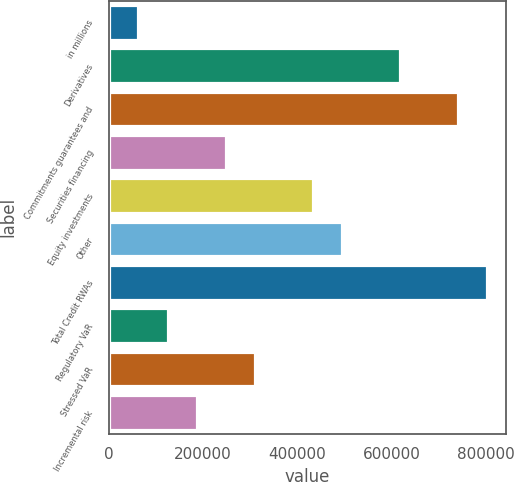Convert chart. <chart><loc_0><loc_0><loc_500><loc_500><bar_chart><fcel>in millions<fcel>Derivatives<fcel>Commitments guarantees and<fcel>Securities financing<fcel>Equity investments<fcel>Other<fcel>Total Credit RWAs<fcel>Regulatory VaR<fcel>Stressed VaR<fcel>Incremental risk<nl><fcel>63447.6<fcel>617646<fcel>740801<fcel>248180<fcel>432913<fcel>494491<fcel>802379<fcel>125025<fcel>309758<fcel>186603<nl></chart> 